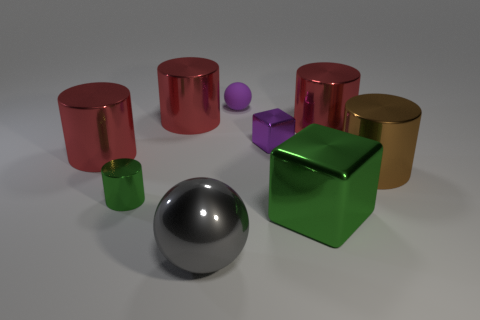There is a tiny object that is the same shape as the large gray thing; what is it made of?
Make the answer very short. Rubber. The gray ball that is the same material as the brown cylinder is what size?
Your response must be concise. Large. Does the large metal thing in front of the green cube have the same shape as the purple thing to the left of the tiny metal cube?
Your answer should be very brief. Yes. What color is the small block that is the same material as the large green cube?
Your answer should be very brief. Purple. There is a green metallic thing that is to the left of the large gray ball; does it have the same size as the metallic cube that is behind the large block?
Give a very brief answer. Yes. There is a big object that is both right of the tiny matte ball and in front of the brown metal thing; what is its shape?
Keep it short and to the point. Cube. Are there any other small things made of the same material as the brown thing?
Keep it short and to the point. Yes. There is a ball that is the same color as the tiny block; what material is it?
Your response must be concise. Rubber. Do the green thing that is left of the small purple matte sphere and the tiny purple ball right of the large ball have the same material?
Make the answer very short. No. Are there more small gray matte things than small balls?
Offer a terse response. No. 